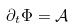Convert formula to latex. <formula><loc_0><loc_0><loc_500><loc_500>\partial _ { t } \Phi = \mathcal { A }</formula> 